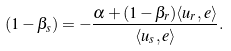<formula> <loc_0><loc_0><loc_500><loc_500>( 1 - \beta _ { s } ) = - \frac { \alpha + ( 1 - \beta _ { r } ) \langle u _ { r } , e \rangle } { \langle u _ { s } , e \rangle } .</formula> 